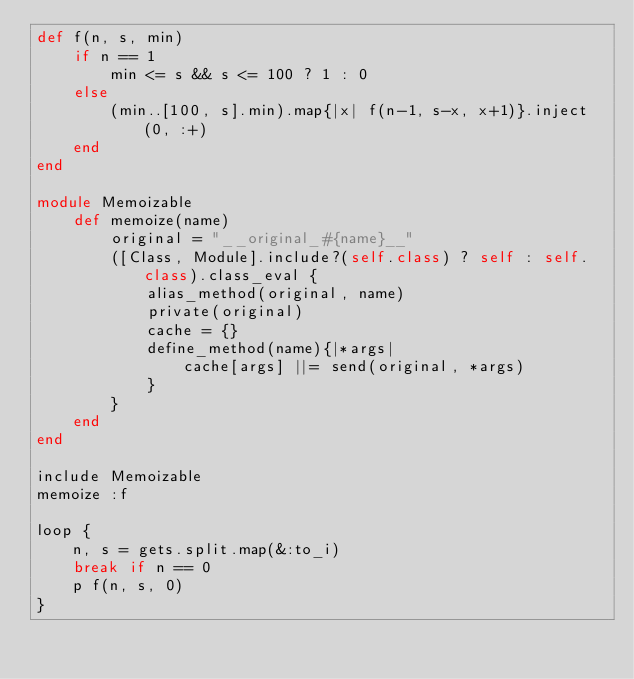<code> <loc_0><loc_0><loc_500><loc_500><_Ruby_>def f(n, s, min)
    if n == 1
        min <= s && s <= 100 ? 1 : 0
    else
        (min..[100, s].min).map{|x| f(n-1, s-x, x+1)}.inject(0, :+)
    end
end

module Memoizable
    def memoize(name)
        original = "__original_#{name}__"
        ([Class, Module].include?(self.class) ? self : self.class).class_eval {
            alias_method(original, name)
            private(original)
            cache = {}
            define_method(name){|*args|
                cache[args] ||= send(original, *args)
            }
        }
    end
end

include Memoizable
memoize :f

loop {
    n, s = gets.split.map(&:to_i)
    break if n == 0
    p f(n, s, 0)
}</code> 